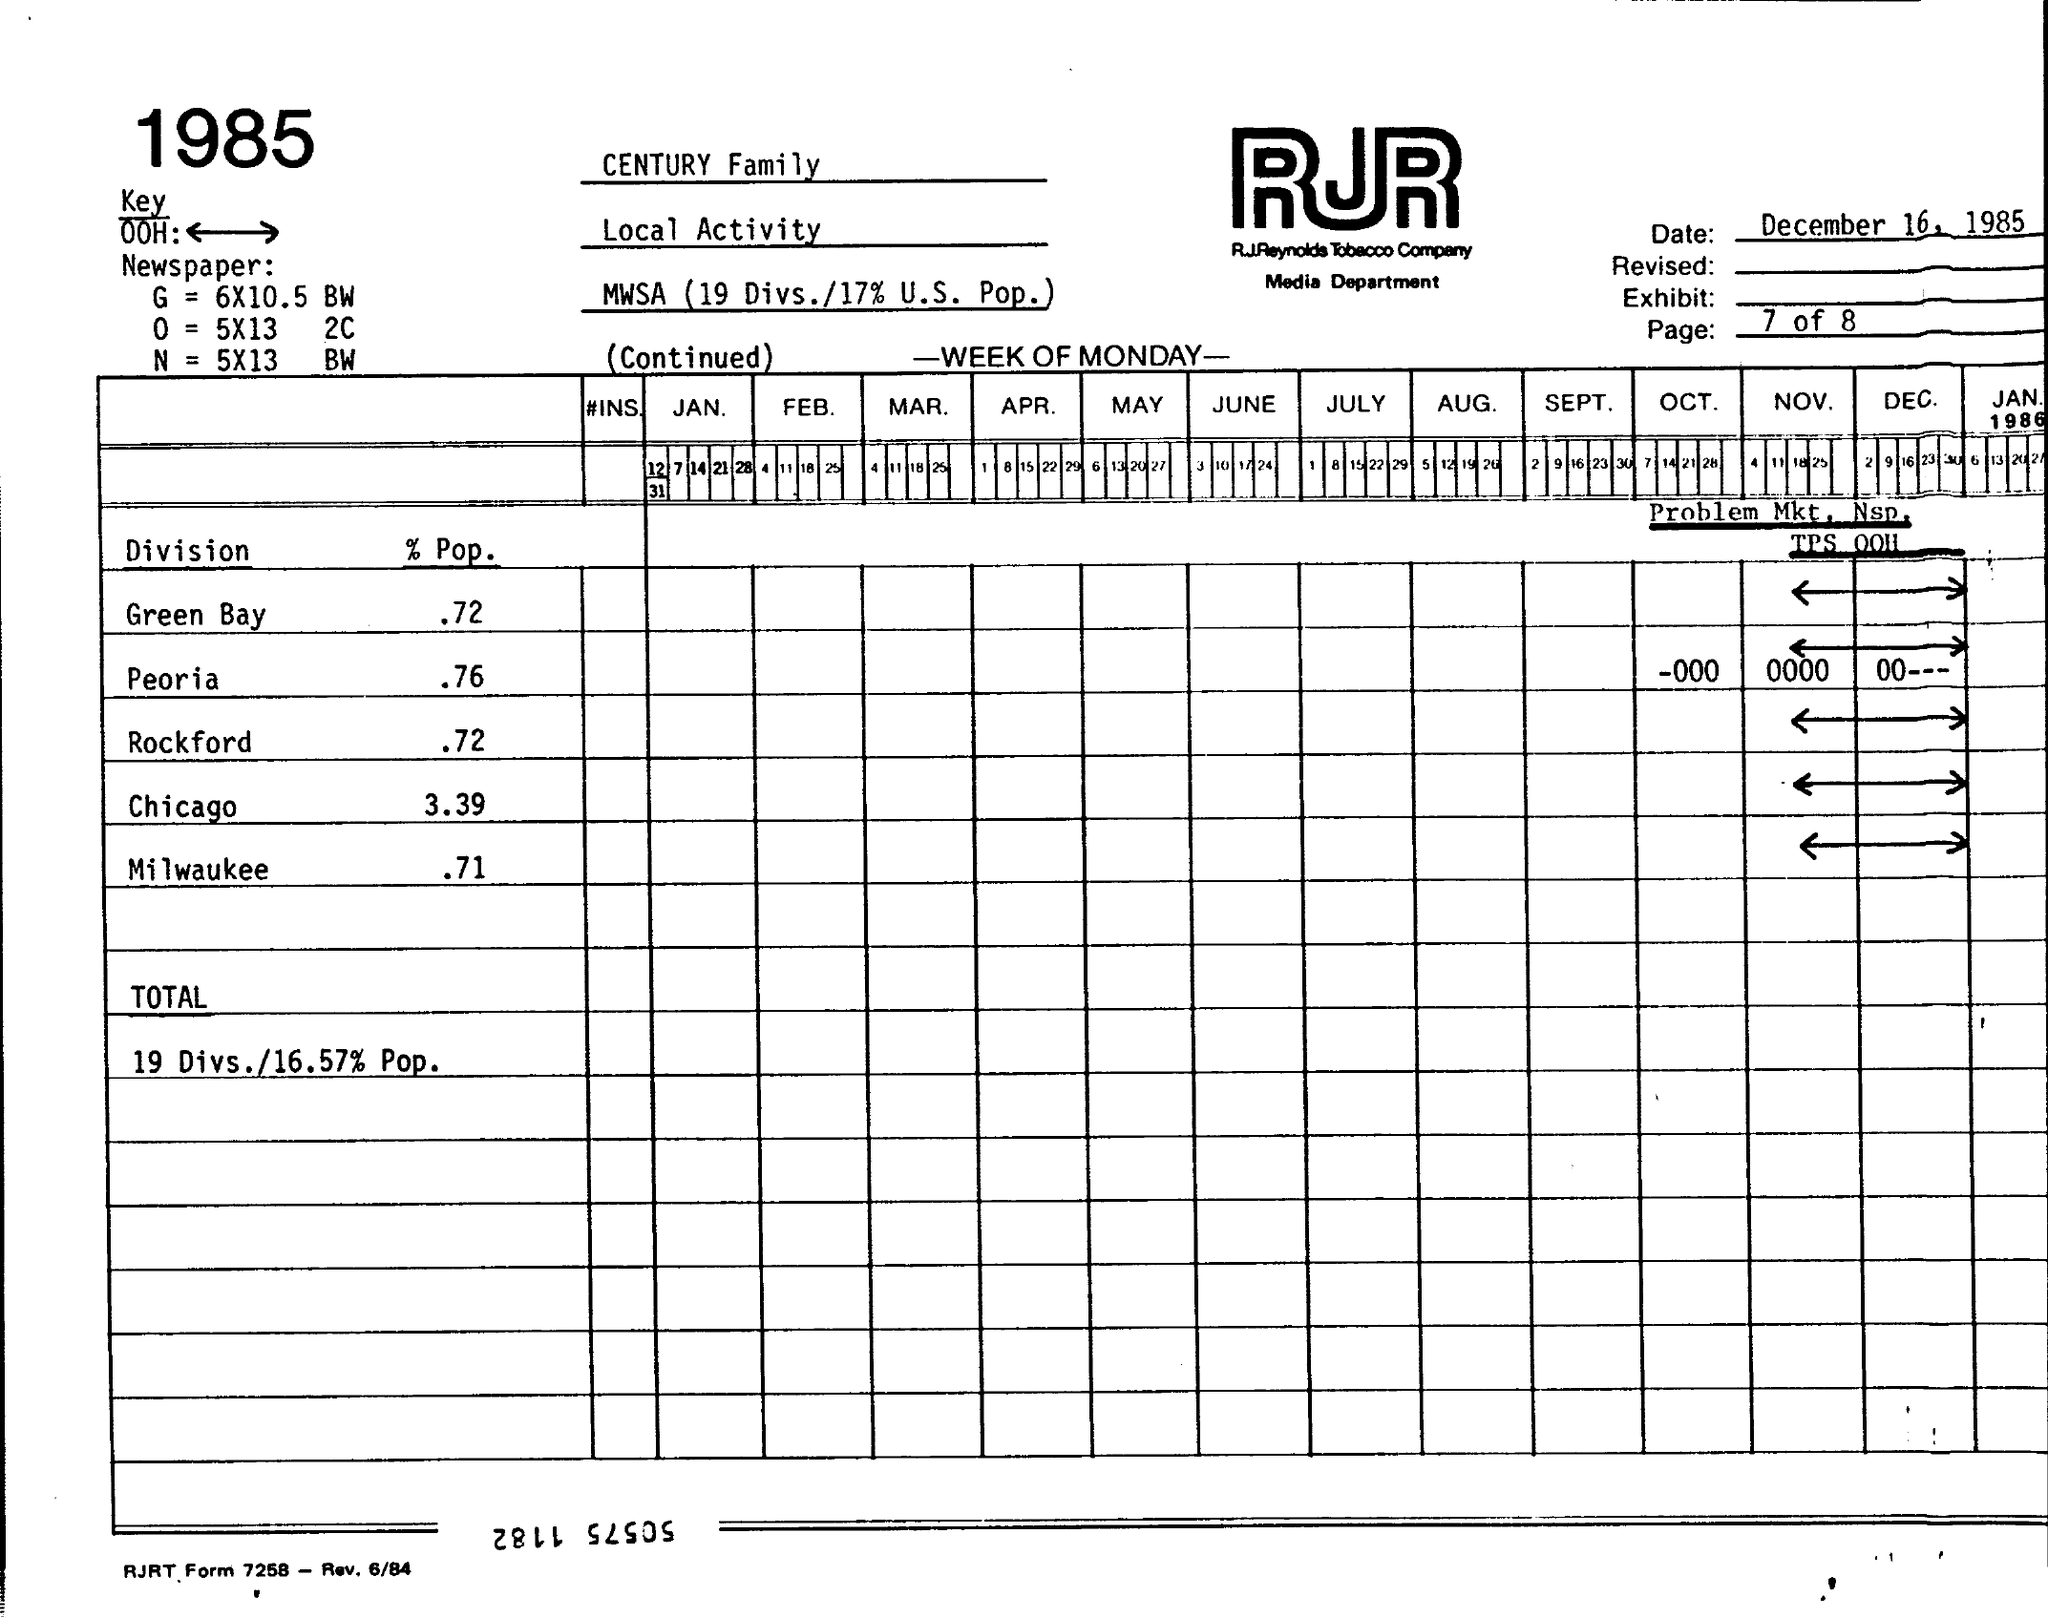Identify some key points in this picture. The year mentioned on the left top of the page is 1985. The "% Pop." value for the Peoria Division is 0.76, which indicates the percentage of the population that is represented by the data. The "% Pop." value for the Milwaukee Division is 0.71, which indicates the percentage of the population that lives in this division. The date displayed in the top right corner of the page is December 16, 1985. The value of "TOTAL" is 19 Divs./16.57 % Pop, which represents the number of Divs. (divisions) and the percentage of the population that would be needed to achieve a given value. 